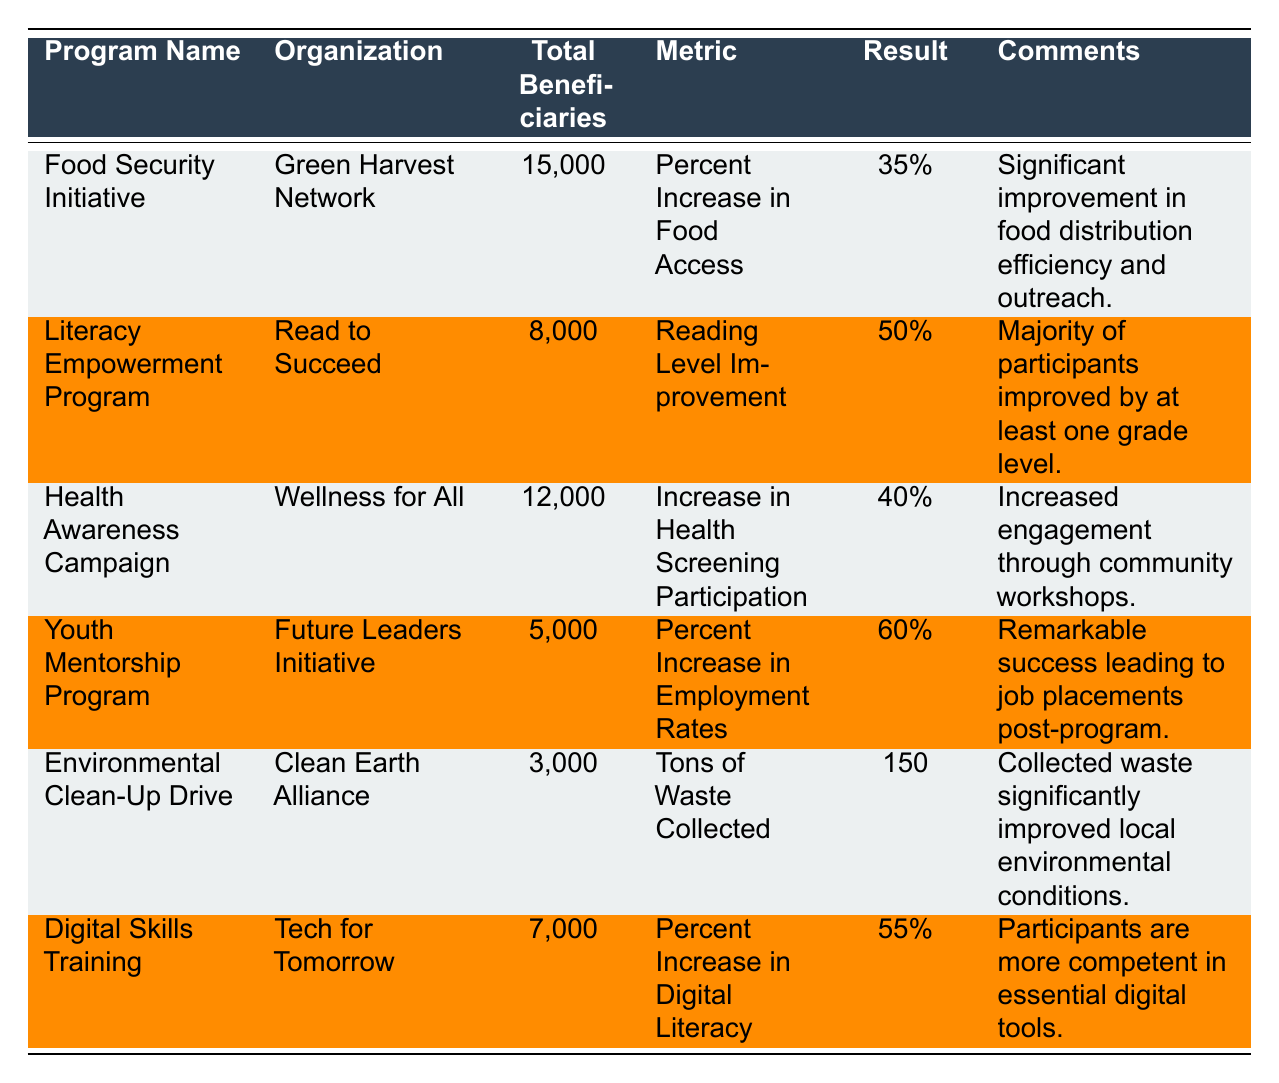What is the program that had the highest percentage increase in its metric? The highest percentage increase in this table is from the Youth Mentorship Program, which had a 60% increase in employment rates.
Answer: Youth Mentorship Program How many total beneficiaries were served by the Food Security Initiative? The table states that the Food Security Initiative served a total of 15,000 beneficiaries.
Answer: 15,000 What was the result of the Literacy Empowerment Program's Reading Level Improvement? The Literacy Empowerment Program achieved a 50% improvement in reading levels among its participants.
Answer: 50% Is the result of the Environmental Clean-Up Drive measured in percent? The result of the Environmental Clean-Up Drive is measured in tons of waste collected, not percent, indicating it is not a percentage-based metric.
Answer: No What is the average percentage increase in the programs that have percentage-based metrics? The percentage increases for three programs are 35%, 50%, 40%, 60%, and 55%. Calculating the average: (35 + 50 + 40 + 60 + 55) / 5 = 48%
Answer: 48% Which program had the least number of total beneficiaries? The program with the least number of beneficiaries is the Environmental Clean-Up Drive, which served 3,000 individuals.
Answer: Environmental Clean-Up Drive How many more total beneficiaries did the Health Awareness Campaign serve compared to the Environmental Clean-Up Drive? The Health Awareness Campaign had 12,000 beneficiaries, while the Environmental Clean-Up Drive had 3,000. The difference is 12,000 - 3,000 = 9,000 beneficiaries.
Answer: 9,000 Which organization had the highest engagement among its beneficiaries according to the comments? The Youth Mentorship Program is noted for its remarkable success leading to job placements, indicating high engagement among its beneficiaries.
Answer: Future Leaders Initiative Did any program achieve a result that exceeded 50%? Yes, the Youth Mentorship Program achieved a result of 60%, which exceeds 50%.
Answer: Yes Which two programs had similar total beneficiary counts, and what are those counts? The Literacy Empowerment Program with 8,000 beneficiaries and the Digital Skills Training Program with 7,000 beneficiaries are somewhat similar; both are in the thousands.
Answer: 8,000 and 7,000 